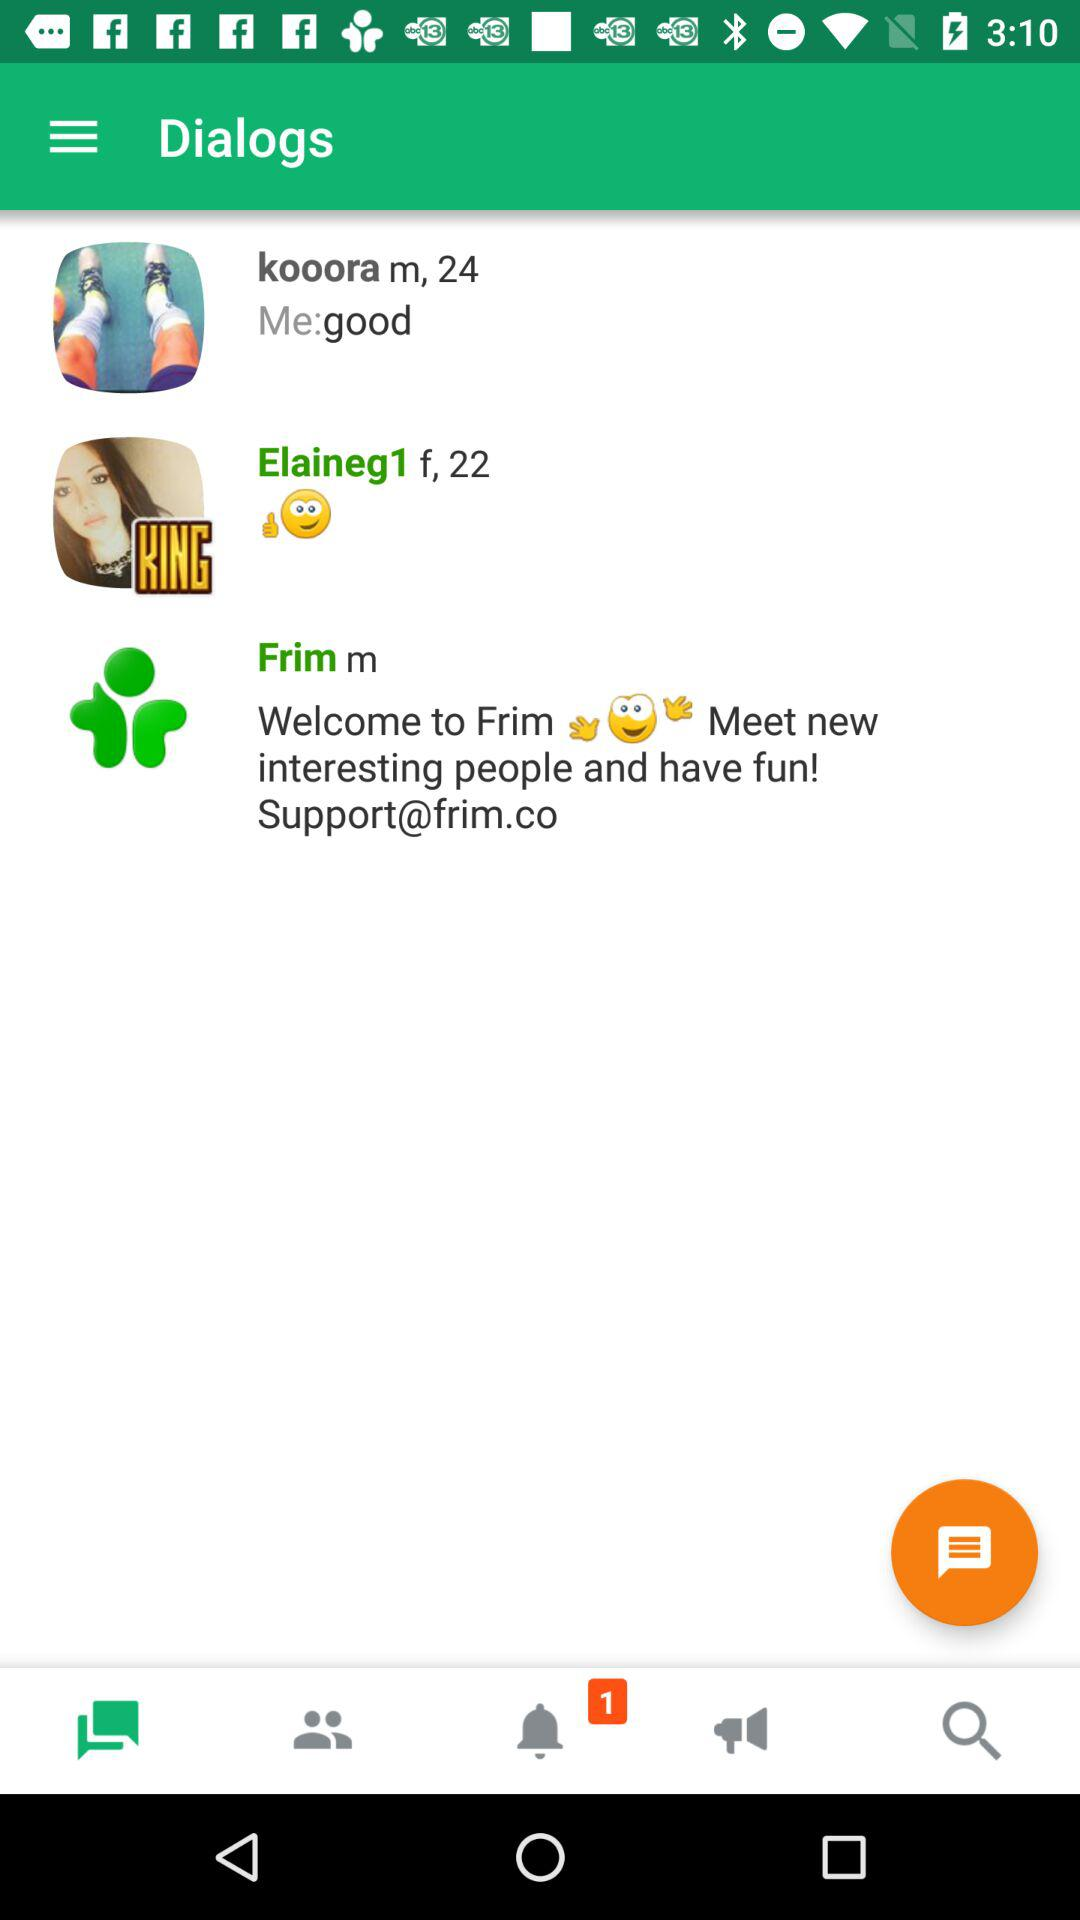What is the age of "kooora"? The age of "kooora" is 24. 